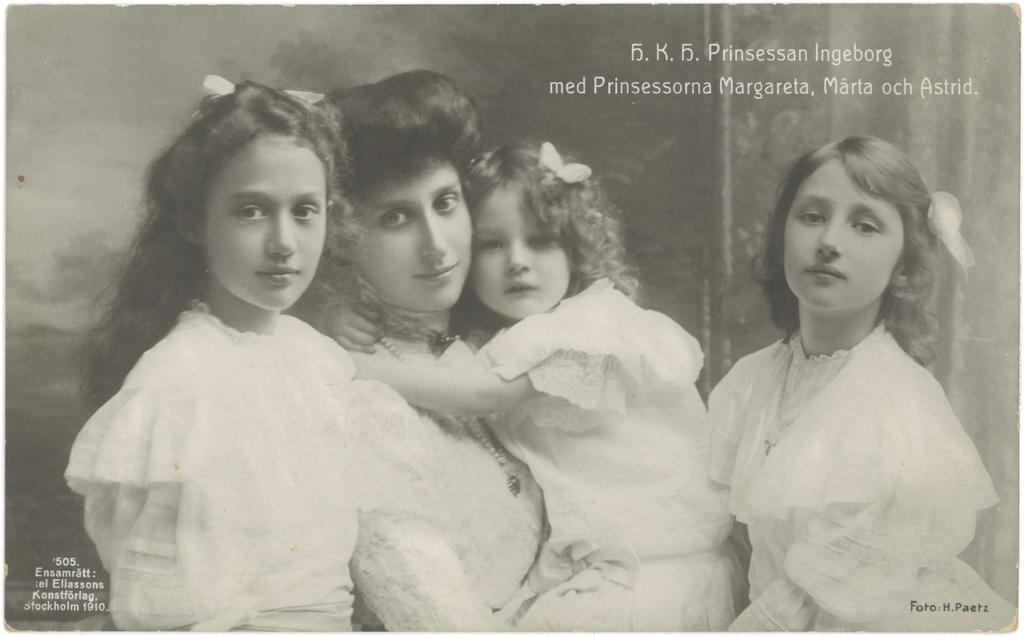Who is the main subject in the image? There is a lady in the image. What is the lady doing in the image? The lady is holding a kid. How many girls are present in the image? There are two girls in the image. Where are the girls positioned in relation to the lady and the kid? The girls are positioned on both sides of the lady and the kid. What type of pancake is being served in the image? There is no pancake present in the image. Is there a patch on the lady's clothing in the image? The provided facts do not mention any patches on the lady's clothing, so we cannot determine if there is a patch or not. 